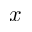Convert formula to latex. <formula><loc_0><loc_0><loc_500><loc_500>x</formula> 